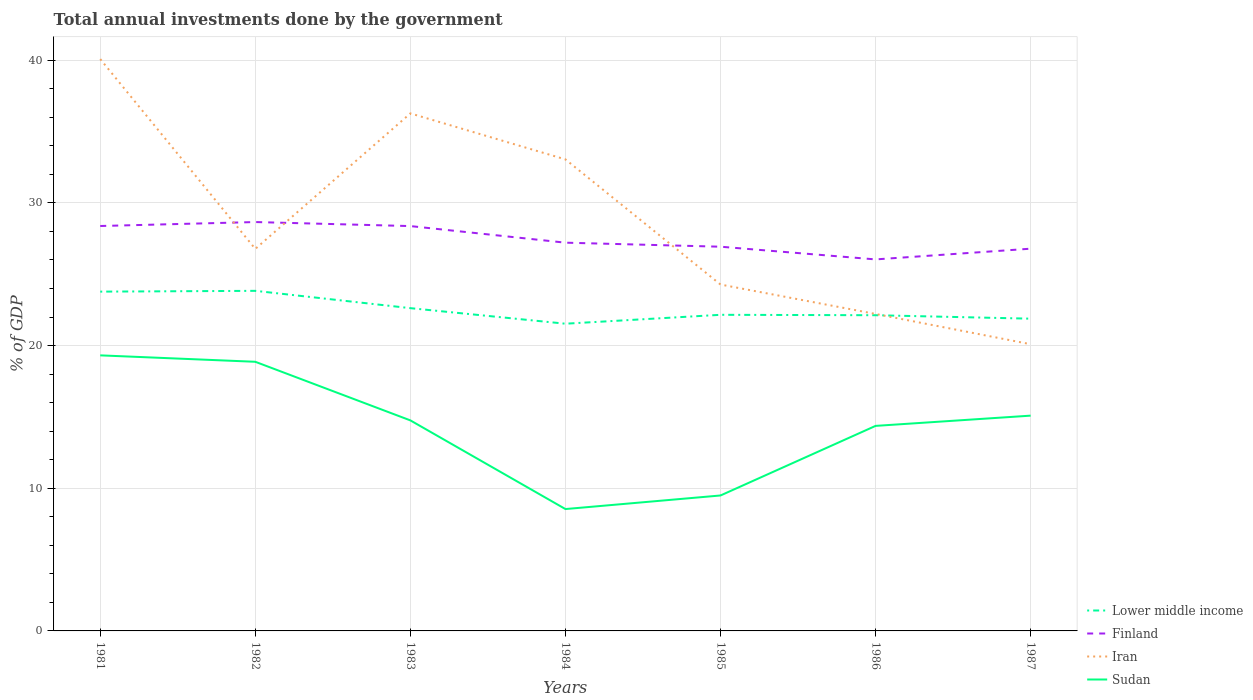How many different coloured lines are there?
Your response must be concise. 4. Does the line corresponding to Iran intersect with the line corresponding to Finland?
Ensure brevity in your answer.  Yes. Is the number of lines equal to the number of legend labels?
Make the answer very short. Yes. Across all years, what is the maximum total annual investments done by the government in Sudan?
Offer a very short reply. 8.54. In which year was the total annual investments done by the government in Iran maximum?
Offer a terse response. 1987. What is the total total annual investments done by the government in Sudan in the graph?
Your answer should be compact. 5.26. What is the difference between the highest and the second highest total annual investments done by the government in Lower middle income?
Provide a short and direct response. 2.3. What is the difference between the highest and the lowest total annual investments done by the government in Lower middle income?
Your answer should be very brief. 3. How many lines are there?
Provide a succinct answer. 4. How many years are there in the graph?
Your response must be concise. 7. Where does the legend appear in the graph?
Your answer should be very brief. Bottom right. How many legend labels are there?
Ensure brevity in your answer.  4. What is the title of the graph?
Your answer should be compact. Total annual investments done by the government. Does "Brunei Darussalam" appear as one of the legend labels in the graph?
Give a very brief answer. No. What is the label or title of the X-axis?
Ensure brevity in your answer.  Years. What is the label or title of the Y-axis?
Make the answer very short. % of GDP. What is the % of GDP in Lower middle income in 1981?
Give a very brief answer. 23.78. What is the % of GDP of Finland in 1981?
Offer a very short reply. 28.38. What is the % of GDP in Iran in 1981?
Ensure brevity in your answer.  40.08. What is the % of GDP in Sudan in 1981?
Your answer should be very brief. 19.31. What is the % of GDP in Lower middle income in 1982?
Keep it short and to the point. 23.83. What is the % of GDP in Finland in 1982?
Your response must be concise. 28.65. What is the % of GDP of Iran in 1982?
Provide a succinct answer. 26.77. What is the % of GDP in Sudan in 1982?
Provide a short and direct response. 18.86. What is the % of GDP in Lower middle income in 1983?
Provide a short and direct response. 22.62. What is the % of GDP of Finland in 1983?
Keep it short and to the point. 28.37. What is the % of GDP of Iran in 1983?
Provide a short and direct response. 36.27. What is the % of GDP in Sudan in 1983?
Your response must be concise. 14.75. What is the % of GDP of Lower middle income in 1984?
Give a very brief answer. 21.53. What is the % of GDP of Finland in 1984?
Provide a succinct answer. 27.21. What is the % of GDP in Iran in 1984?
Ensure brevity in your answer.  33.05. What is the % of GDP in Sudan in 1984?
Provide a short and direct response. 8.54. What is the % of GDP in Lower middle income in 1985?
Provide a short and direct response. 22.15. What is the % of GDP of Finland in 1985?
Offer a very short reply. 26.93. What is the % of GDP in Iran in 1985?
Your response must be concise. 24.27. What is the % of GDP in Sudan in 1985?
Make the answer very short. 9.49. What is the % of GDP of Lower middle income in 1986?
Provide a short and direct response. 22.13. What is the % of GDP of Finland in 1986?
Your answer should be compact. 26.04. What is the % of GDP in Iran in 1986?
Your answer should be compact. 22.21. What is the % of GDP of Sudan in 1986?
Keep it short and to the point. 14.37. What is the % of GDP in Lower middle income in 1987?
Keep it short and to the point. 21.88. What is the % of GDP of Finland in 1987?
Offer a terse response. 26.79. What is the % of GDP in Iran in 1987?
Your answer should be very brief. 20.09. What is the % of GDP in Sudan in 1987?
Offer a very short reply. 15.09. Across all years, what is the maximum % of GDP in Lower middle income?
Make the answer very short. 23.83. Across all years, what is the maximum % of GDP in Finland?
Provide a short and direct response. 28.65. Across all years, what is the maximum % of GDP of Iran?
Offer a terse response. 40.08. Across all years, what is the maximum % of GDP of Sudan?
Provide a short and direct response. 19.31. Across all years, what is the minimum % of GDP of Lower middle income?
Keep it short and to the point. 21.53. Across all years, what is the minimum % of GDP in Finland?
Keep it short and to the point. 26.04. Across all years, what is the minimum % of GDP of Iran?
Make the answer very short. 20.09. Across all years, what is the minimum % of GDP of Sudan?
Provide a short and direct response. 8.54. What is the total % of GDP of Lower middle income in the graph?
Your answer should be compact. 157.92. What is the total % of GDP in Finland in the graph?
Offer a terse response. 192.36. What is the total % of GDP in Iran in the graph?
Your response must be concise. 202.74. What is the total % of GDP of Sudan in the graph?
Make the answer very short. 100.42. What is the difference between the % of GDP of Lower middle income in 1981 and that in 1982?
Ensure brevity in your answer.  -0.06. What is the difference between the % of GDP in Finland in 1981 and that in 1982?
Keep it short and to the point. -0.28. What is the difference between the % of GDP of Iran in 1981 and that in 1982?
Offer a very short reply. 13.3. What is the difference between the % of GDP of Sudan in 1981 and that in 1982?
Keep it short and to the point. 0.45. What is the difference between the % of GDP in Lower middle income in 1981 and that in 1983?
Offer a terse response. 1.16. What is the difference between the % of GDP of Finland in 1981 and that in 1983?
Offer a very short reply. 0.01. What is the difference between the % of GDP of Iran in 1981 and that in 1983?
Give a very brief answer. 3.81. What is the difference between the % of GDP in Sudan in 1981 and that in 1983?
Offer a terse response. 4.56. What is the difference between the % of GDP of Lower middle income in 1981 and that in 1984?
Provide a succinct answer. 2.25. What is the difference between the % of GDP in Finland in 1981 and that in 1984?
Provide a succinct answer. 1.17. What is the difference between the % of GDP in Iran in 1981 and that in 1984?
Provide a short and direct response. 7.03. What is the difference between the % of GDP in Sudan in 1981 and that in 1984?
Offer a very short reply. 10.77. What is the difference between the % of GDP of Lower middle income in 1981 and that in 1985?
Provide a short and direct response. 1.62. What is the difference between the % of GDP of Finland in 1981 and that in 1985?
Give a very brief answer. 1.45. What is the difference between the % of GDP of Iran in 1981 and that in 1985?
Make the answer very short. 15.8. What is the difference between the % of GDP of Sudan in 1981 and that in 1985?
Your response must be concise. 9.82. What is the difference between the % of GDP in Lower middle income in 1981 and that in 1986?
Provide a succinct answer. 1.65. What is the difference between the % of GDP in Finland in 1981 and that in 1986?
Make the answer very short. 2.34. What is the difference between the % of GDP of Iran in 1981 and that in 1986?
Your response must be concise. 17.86. What is the difference between the % of GDP of Sudan in 1981 and that in 1986?
Offer a very short reply. 4.94. What is the difference between the % of GDP of Lower middle income in 1981 and that in 1987?
Provide a succinct answer. 1.9. What is the difference between the % of GDP in Finland in 1981 and that in 1987?
Provide a short and direct response. 1.59. What is the difference between the % of GDP in Iran in 1981 and that in 1987?
Your response must be concise. 19.98. What is the difference between the % of GDP of Sudan in 1981 and that in 1987?
Offer a very short reply. 4.22. What is the difference between the % of GDP in Lower middle income in 1982 and that in 1983?
Provide a succinct answer. 1.21. What is the difference between the % of GDP of Finland in 1982 and that in 1983?
Ensure brevity in your answer.  0.28. What is the difference between the % of GDP of Iran in 1982 and that in 1983?
Your answer should be compact. -9.5. What is the difference between the % of GDP in Sudan in 1982 and that in 1983?
Your answer should be compact. 4.11. What is the difference between the % of GDP in Lower middle income in 1982 and that in 1984?
Offer a terse response. 2.3. What is the difference between the % of GDP in Finland in 1982 and that in 1984?
Offer a terse response. 1.45. What is the difference between the % of GDP of Iran in 1982 and that in 1984?
Offer a terse response. -6.27. What is the difference between the % of GDP of Sudan in 1982 and that in 1984?
Make the answer very short. 10.32. What is the difference between the % of GDP of Lower middle income in 1982 and that in 1985?
Keep it short and to the point. 1.68. What is the difference between the % of GDP in Finland in 1982 and that in 1985?
Your response must be concise. 1.73. What is the difference between the % of GDP in Iran in 1982 and that in 1985?
Offer a terse response. 2.5. What is the difference between the % of GDP of Sudan in 1982 and that in 1985?
Offer a terse response. 9.37. What is the difference between the % of GDP of Lower middle income in 1982 and that in 1986?
Give a very brief answer. 1.71. What is the difference between the % of GDP in Finland in 1982 and that in 1986?
Offer a terse response. 2.62. What is the difference between the % of GDP of Iran in 1982 and that in 1986?
Keep it short and to the point. 4.56. What is the difference between the % of GDP of Sudan in 1982 and that in 1986?
Offer a terse response. 4.49. What is the difference between the % of GDP of Lower middle income in 1982 and that in 1987?
Offer a terse response. 1.95. What is the difference between the % of GDP in Finland in 1982 and that in 1987?
Make the answer very short. 1.87. What is the difference between the % of GDP of Iran in 1982 and that in 1987?
Give a very brief answer. 6.68. What is the difference between the % of GDP in Sudan in 1982 and that in 1987?
Keep it short and to the point. 3.77. What is the difference between the % of GDP of Lower middle income in 1983 and that in 1984?
Your answer should be compact. 1.09. What is the difference between the % of GDP in Finland in 1983 and that in 1984?
Your response must be concise. 1.16. What is the difference between the % of GDP in Iran in 1983 and that in 1984?
Your answer should be compact. 3.22. What is the difference between the % of GDP in Sudan in 1983 and that in 1984?
Offer a terse response. 6.21. What is the difference between the % of GDP of Lower middle income in 1983 and that in 1985?
Offer a terse response. 0.47. What is the difference between the % of GDP of Finland in 1983 and that in 1985?
Offer a very short reply. 1.45. What is the difference between the % of GDP of Iran in 1983 and that in 1985?
Offer a very short reply. 11.99. What is the difference between the % of GDP in Sudan in 1983 and that in 1985?
Provide a short and direct response. 5.26. What is the difference between the % of GDP of Lower middle income in 1983 and that in 1986?
Provide a succinct answer. 0.5. What is the difference between the % of GDP in Finland in 1983 and that in 1986?
Offer a terse response. 2.34. What is the difference between the % of GDP in Iran in 1983 and that in 1986?
Give a very brief answer. 14.06. What is the difference between the % of GDP in Sudan in 1983 and that in 1986?
Make the answer very short. 0.38. What is the difference between the % of GDP of Lower middle income in 1983 and that in 1987?
Keep it short and to the point. 0.74. What is the difference between the % of GDP of Finland in 1983 and that in 1987?
Ensure brevity in your answer.  1.58. What is the difference between the % of GDP of Iran in 1983 and that in 1987?
Give a very brief answer. 16.18. What is the difference between the % of GDP in Sudan in 1983 and that in 1987?
Your answer should be compact. -0.33. What is the difference between the % of GDP of Lower middle income in 1984 and that in 1985?
Give a very brief answer. -0.62. What is the difference between the % of GDP of Finland in 1984 and that in 1985?
Keep it short and to the point. 0.28. What is the difference between the % of GDP of Iran in 1984 and that in 1985?
Provide a succinct answer. 8.77. What is the difference between the % of GDP of Sudan in 1984 and that in 1985?
Give a very brief answer. -0.95. What is the difference between the % of GDP in Lower middle income in 1984 and that in 1986?
Offer a terse response. -0.59. What is the difference between the % of GDP of Finland in 1984 and that in 1986?
Make the answer very short. 1.17. What is the difference between the % of GDP in Iran in 1984 and that in 1986?
Make the answer very short. 10.83. What is the difference between the % of GDP in Sudan in 1984 and that in 1986?
Keep it short and to the point. -5.83. What is the difference between the % of GDP of Lower middle income in 1984 and that in 1987?
Your response must be concise. -0.35. What is the difference between the % of GDP of Finland in 1984 and that in 1987?
Offer a very short reply. 0.42. What is the difference between the % of GDP in Iran in 1984 and that in 1987?
Ensure brevity in your answer.  12.95. What is the difference between the % of GDP of Sudan in 1984 and that in 1987?
Make the answer very short. -6.55. What is the difference between the % of GDP of Lower middle income in 1985 and that in 1986?
Ensure brevity in your answer.  0.03. What is the difference between the % of GDP in Finland in 1985 and that in 1986?
Provide a short and direct response. 0.89. What is the difference between the % of GDP of Iran in 1985 and that in 1986?
Ensure brevity in your answer.  2.06. What is the difference between the % of GDP of Sudan in 1985 and that in 1986?
Your answer should be very brief. -4.88. What is the difference between the % of GDP of Lower middle income in 1985 and that in 1987?
Make the answer very short. 0.27. What is the difference between the % of GDP of Finland in 1985 and that in 1987?
Make the answer very short. 0.14. What is the difference between the % of GDP of Iran in 1985 and that in 1987?
Your answer should be very brief. 4.18. What is the difference between the % of GDP of Sudan in 1985 and that in 1987?
Provide a short and direct response. -5.59. What is the difference between the % of GDP of Lower middle income in 1986 and that in 1987?
Your answer should be compact. 0.24. What is the difference between the % of GDP of Finland in 1986 and that in 1987?
Your answer should be very brief. -0.75. What is the difference between the % of GDP of Iran in 1986 and that in 1987?
Keep it short and to the point. 2.12. What is the difference between the % of GDP in Sudan in 1986 and that in 1987?
Your answer should be very brief. -0.72. What is the difference between the % of GDP of Lower middle income in 1981 and the % of GDP of Finland in 1982?
Give a very brief answer. -4.88. What is the difference between the % of GDP in Lower middle income in 1981 and the % of GDP in Iran in 1982?
Your answer should be very brief. -3. What is the difference between the % of GDP of Lower middle income in 1981 and the % of GDP of Sudan in 1982?
Offer a terse response. 4.92. What is the difference between the % of GDP in Finland in 1981 and the % of GDP in Iran in 1982?
Make the answer very short. 1.6. What is the difference between the % of GDP of Finland in 1981 and the % of GDP of Sudan in 1982?
Your answer should be compact. 9.52. What is the difference between the % of GDP of Iran in 1981 and the % of GDP of Sudan in 1982?
Your answer should be compact. 21.21. What is the difference between the % of GDP of Lower middle income in 1981 and the % of GDP of Finland in 1983?
Your response must be concise. -4.59. What is the difference between the % of GDP of Lower middle income in 1981 and the % of GDP of Iran in 1983?
Your answer should be compact. -12.49. What is the difference between the % of GDP of Lower middle income in 1981 and the % of GDP of Sudan in 1983?
Your answer should be compact. 9.02. What is the difference between the % of GDP of Finland in 1981 and the % of GDP of Iran in 1983?
Ensure brevity in your answer.  -7.89. What is the difference between the % of GDP of Finland in 1981 and the % of GDP of Sudan in 1983?
Your answer should be compact. 13.62. What is the difference between the % of GDP of Iran in 1981 and the % of GDP of Sudan in 1983?
Offer a terse response. 25.32. What is the difference between the % of GDP in Lower middle income in 1981 and the % of GDP in Finland in 1984?
Provide a short and direct response. -3.43. What is the difference between the % of GDP in Lower middle income in 1981 and the % of GDP in Iran in 1984?
Give a very brief answer. -9.27. What is the difference between the % of GDP in Lower middle income in 1981 and the % of GDP in Sudan in 1984?
Your answer should be compact. 15.24. What is the difference between the % of GDP in Finland in 1981 and the % of GDP in Iran in 1984?
Make the answer very short. -4.67. What is the difference between the % of GDP of Finland in 1981 and the % of GDP of Sudan in 1984?
Your answer should be very brief. 19.84. What is the difference between the % of GDP of Iran in 1981 and the % of GDP of Sudan in 1984?
Offer a terse response. 31.54. What is the difference between the % of GDP of Lower middle income in 1981 and the % of GDP of Finland in 1985?
Your answer should be very brief. -3.15. What is the difference between the % of GDP of Lower middle income in 1981 and the % of GDP of Iran in 1985?
Make the answer very short. -0.5. What is the difference between the % of GDP of Lower middle income in 1981 and the % of GDP of Sudan in 1985?
Offer a very short reply. 14.29. What is the difference between the % of GDP of Finland in 1981 and the % of GDP of Iran in 1985?
Provide a succinct answer. 4.1. What is the difference between the % of GDP in Finland in 1981 and the % of GDP in Sudan in 1985?
Provide a succinct answer. 18.88. What is the difference between the % of GDP in Iran in 1981 and the % of GDP in Sudan in 1985?
Provide a short and direct response. 30.58. What is the difference between the % of GDP of Lower middle income in 1981 and the % of GDP of Finland in 1986?
Keep it short and to the point. -2.26. What is the difference between the % of GDP of Lower middle income in 1981 and the % of GDP of Iran in 1986?
Offer a terse response. 1.56. What is the difference between the % of GDP of Lower middle income in 1981 and the % of GDP of Sudan in 1986?
Offer a very short reply. 9.41. What is the difference between the % of GDP of Finland in 1981 and the % of GDP of Iran in 1986?
Offer a very short reply. 6.16. What is the difference between the % of GDP in Finland in 1981 and the % of GDP in Sudan in 1986?
Your answer should be very brief. 14.01. What is the difference between the % of GDP in Iran in 1981 and the % of GDP in Sudan in 1986?
Provide a succinct answer. 25.71. What is the difference between the % of GDP in Lower middle income in 1981 and the % of GDP in Finland in 1987?
Keep it short and to the point. -3.01. What is the difference between the % of GDP of Lower middle income in 1981 and the % of GDP of Iran in 1987?
Your response must be concise. 3.69. What is the difference between the % of GDP in Lower middle income in 1981 and the % of GDP in Sudan in 1987?
Make the answer very short. 8.69. What is the difference between the % of GDP in Finland in 1981 and the % of GDP in Iran in 1987?
Your answer should be compact. 8.28. What is the difference between the % of GDP of Finland in 1981 and the % of GDP of Sudan in 1987?
Ensure brevity in your answer.  13.29. What is the difference between the % of GDP of Iran in 1981 and the % of GDP of Sudan in 1987?
Your answer should be compact. 24.99. What is the difference between the % of GDP in Lower middle income in 1982 and the % of GDP in Finland in 1983?
Your response must be concise. -4.54. What is the difference between the % of GDP of Lower middle income in 1982 and the % of GDP of Iran in 1983?
Your answer should be very brief. -12.43. What is the difference between the % of GDP of Lower middle income in 1982 and the % of GDP of Sudan in 1983?
Your answer should be very brief. 9.08. What is the difference between the % of GDP of Finland in 1982 and the % of GDP of Iran in 1983?
Your response must be concise. -7.61. What is the difference between the % of GDP in Finland in 1982 and the % of GDP in Sudan in 1983?
Your response must be concise. 13.9. What is the difference between the % of GDP in Iran in 1982 and the % of GDP in Sudan in 1983?
Give a very brief answer. 12.02. What is the difference between the % of GDP in Lower middle income in 1982 and the % of GDP in Finland in 1984?
Your response must be concise. -3.38. What is the difference between the % of GDP in Lower middle income in 1982 and the % of GDP in Iran in 1984?
Your answer should be very brief. -9.21. What is the difference between the % of GDP in Lower middle income in 1982 and the % of GDP in Sudan in 1984?
Give a very brief answer. 15.29. What is the difference between the % of GDP of Finland in 1982 and the % of GDP of Iran in 1984?
Give a very brief answer. -4.39. What is the difference between the % of GDP of Finland in 1982 and the % of GDP of Sudan in 1984?
Your answer should be compact. 20.11. What is the difference between the % of GDP in Iran in 1982 and the % of GDP in Sudan in 1984?
Your answer should be very brief. 18.23. What is the difference between the % of GDP of Lower middle income in 1982 and the % of GDP of Finland in 1985?
Keep it short and to the point. -3.09. What is the difference between the % of GDP of Lower middle income in 1982 and the % of GDP of Iran in 1985?
Your answer should be very brief. -0.44. What is the difference between the % of GDP of Lower middle income in 1982 and the % of GDP of Sudan in 1985?
Your answer should be very brief. 14.34. What is the difference between the % of GDP of Finland in 1982 and the % of GDP of Iran in 1985?
Keep it short and to the point. 4.38. What is the difference between the % of GDP of Finland in 1982 and the % of GDP of Sudan in 1985?
Your response must be concise. 19.16. What is the difference between the % of GDP of Iran in 1982 and the % of GDP of Sudan in 1985?
Offer a terse response. 17.28. What is the difference between the % of GDP in Lower middle income in 1982 and the % of GDP in Finland in 1986?
Your answer should be compact. -2.2. What is the difference between the % of GDP in Lower middle income in 1982 and the % of GDP in Iran in 1986?
Keep it short and to the point. 1.62. What is the difference between the % of GDP in Lower middle income in 1982 and the % of GDP in Sudan in 1986?
Give a very brief answer. 9.46. What is the difference between the % of GDP of Finland in 1982 and the % of GDP of Iran in 1986?
Ensure brevity in your answer.  6.44. What is the difference between the % of GDP in Finland in 1982 and the % of GDP in Sudan in 1986?
Provide a short and direct response. 14.29. What is the difference between the % of GDP of Iran in 1982 and the % of GDP of Sudan in 1986?
Ensure brevity in your answer.  12.4. What is the difference between the % of GDP in Lower middle income in 1982 and the % of GDP in Finland in 1987?
Your answer should be very brief. -2.95. What is the difference between the % of GDP of Lower middle income in 1982 and the % of GDP of Iran in 1987?
Provide a succinct answer. 3.74. What is the difference between the % of GDP of Lower middle income in 1982 and the % of GDP of Sudan in 1987?
Your answer should be very brief. 8.75. What is the difference between the % of GDP of Finland in 1982 and the % of GDP of Iran in 1987?
Ensure brevity in your answer.  8.56. What is the difference between the % of GDP in Finland in 1982 and the % of GDP in Sudan in 1987?
Your answer should be compact. 13.57. What is the difference between the % of GDP of Iran in 1982 and the % of GDP of Sudan in 1987?
Give a very brief answer. 11.69. What is the difference between the % of GDP in Lower middle income in 1983 and the % of GDP in Finland in 1984?
Your answer should be compact. -4.59. What is the difference between the % of GDP of Lower middle income in 1983 and the % of GDP of Iran in 1984?
Ensure brevity in your answer.  -10.43. What is the difference between the % of GDP of Lower middle income in 1983 and the % of GDP of Sudan in 1984?
Offer a terse response. 14.08. What is the difference between the % of GDP of Finland in 1983 and the % of GDP of Iran in 1984?
Provide a succinct answer. -4.67. What is the difference between the % of GDP of Finland in 1983 and the % of GDP of Sudan in 1984?
Ensure brevity in your answer.  19.83. What is the difference between the % of GDP in Iran in 1983 and the % of GDP in Sudan in 1984?
Your response must be concise. 27.73. What is the difference between the % of GDP of Lower middle income in 1983 and the % of GDP of Finland in 1985?
Offer a very short reply. -4.31. What is the difference between the % of GDP of Lower middle income in 1983 and the % of GDP of Iran in 1985?
Provide a short and direct response. -1.65. What is the difference between the % of GDP of Lower middle income in 1983 and the % of GDP of Sudan in 1985?
Your response must be concise. 13.13. What is the difference between the % of GDP of Finland in 1983 and the % of GDP of Iran in 1985?
Provide a short and direct response. 4.1. What is the difference between the % of GDP in Finland in 1983 and the % of GDP in Sudan in 1985?
Provide a succinct answer. 18.88. What is the difference between the % of GDP of Iran in 1983 and the % of GDP of Sudan in 1985?
Keep it short and to the point. 26.78. What is the difference between the % of GDP of Lower middle income in 1983 and the % of GDP of Finland in 1986?
Provide a short and direct response. -3.42. What is the difference between the % of GDP in Lower middle income in 1983 and the % of GDP in Iran in 1986?
Make the answer very short. 0.41. What is the difference between the % of GDP of Lower middle income in 1983 and the % of GDP of Sudan in 1986?
Make the answer very short. 8.25. What is the difference between the % of GDP in Finland in 1983 and the % of GDP in Iran in 1986?
Keep it short and to the point. 6.16. What is the difference between the % of GDP in Finland in 1983 and the % of GDP in Sudan in 1986?
Offer a very short reply. 14. What is the difference between the % of GDP of Iran in 1983 and the % of GDP of Sudan in 1986?
Your answer should be compact. 21.9. What is the difference between the % of GDP in Lower middle income in 1983 and the % of GDP in Finland in 1987?
Offer a terse response. -4.17. What is the difference between the % of GDP in Lower middle income in 1983 and the % of GDP in Iran in 1987?
Make the answer very short. 2.53. What is the difference between the % of GDP of Lower middle income in 1983 and the % of GDP of Sudan in 1987?
Provide a succinct answer. 7.53. What is the difference between the % of GDP in Finland in 1983 and the % of GDP in Iran in 1987?
Offer a terse response. 8.28. What is the difference between the % of GDP of Finland in 1983 and the % of GDP of Sudan in 1987?
Provide a short and direct response. 13.29. What is the difference between the % of GDP of Iran in 1983 and the % of GDP of Sudan in 1987?
Ensure brevity in your answer.  21.18. What is the difference between the % of GDP of Lower middle income in 1984 and the % of GDP of Finland in 1985?
Ensure brevity in your answer.  -5.4. What is the difference between the % of GDP of Lower middle income in 1984 and the % of GDP of Iran in 1985?
Offer a terse response. -2.74. What is the difference between the % of GDP in Lower middle income in 1984 and the % of GDP in Sudan in 1985?
Your answer should be compact. 12.04. What is the difference between the % of GDP in Finland in 1984 and the % of GDP in Iran in 1985?
Provide a short and direct response. 2.93. What is the difference between the % of GDP in Finland in 1984 and the % of GDP in Sudan in 1985?
Offer a terse response. 17.72. What is the difference between the % of GDP in Iran in 1984 and the % of GDP in Sudan in 1985?
Offer a very short reply. 23.55. What is the difference between the % of GDP in Lower middle income in 1984 and the % of GDP in Finland in 1986?
Offer a terse response. -4.51. What is the difference between the % of GDP of Lower middle income in 1984 and the % of GDP of Iran in 1986?
Offer a very short reply. -0.68. What is the difference between the % of GDP of Lower middle income in 1984 and the % of GDP of Sudan in 1986?
Offer a terse response. 7.16. What is the difference between the % of GDP in Finland in 1984 and the % of GDP in Iran in 1986?
Offer a very short reply. 5. What is the difference between the % of GDP of Finland in 1984 and the % of GDP of Sudan in 1986?
Ensure brevity in your answer.  12.84. What is the difference between the % of GDP in Iran in 1984 and the % of GDP in Sudan in 1986?
Your answer should be very brief. 18.68. What is the difference between the % of GDP in Lower middle income in 1984 and the % of GDP in Finland in 1987?
Your answer should be compact. -5.26. What is the difference between the % of GDP in Lower middle income in 1984 and the % of GDP in Iran in 1987?
Your response must be concise. 1.44. What is the difference between the % of GDP of Lower middle income in 1984 and the % of GDP of Sudan in 1987?
Provide a short and direct response. 6.44. What is the difference between the % of GDP of Finland in 1984 and the % of GDP of Iran in 1987?
Keep it short and to the point. 7.12. What is the difference between the % of GDP of Finland in 1984 and the % of GDP of Sudan in 1987?
Keep it short and to the point. 12.12. What is the difference between the % of GDP in Iran in 1984 and the % of GDP in Sudan in 1987?
Offer a terse response. 17.96. What is the difference between the % of GDP of Lower middle income in 1985 and the % of GDP of Finland in 1986?
Make the answer very short. -3.88. What is the difference between the % of GDP in Lower middle income in 1985 and the % of GDP in Iran in 1986?
Your answer should be very brief. -0.06. What is the difference between the % of GDP in Lower middle income in 1985 and the % of GDP in Sudan in 1986?
Your answer should be very brief. 7.78. What is the difference between the % of GDP of Finland in 1985 and the % of GDP of Iran in 1986?
Ensure brevity in your answer.  4.71. What is the difference between the % of GDP of Finland in 1985 and the % of GDP of Sudan in 1986?
Your response must be concise. 12.56. What is the difference between the % of GDP of Iran in 1985 and the % of GDP of Sudan in 1986?
Your response must be concise. 9.91. What is the difference between the % of GDP of Lower middle income in 1985 and the % of GDP of Finland in 1987?
Give a very brief answer. -4.63. What is the difference between the % of GDP in Lower middle income in 1985 and the % of GDP in Iran in 1987?
Your answer should be compact. 2.06. What is the difference between the % of GDP in Lower middle income in 1985 and the % of GDP in Sudan in 1987?
Your answer should be very brief. 7.07. What is the difference between the % of GDP in Finland in 1985 and the % of GDP in Iran in 1987?
Your response must be concise. 6.83. What is the difference between the % of GDP of Finland in 1985 and the % of GDP of Sudan in 1987?
Offer a very short reply. 11.84. What is the difference between the % of GDP of Iran in 1985 and the % of GDP of Sudan in 1987?
Ensure brevity in your answer.  9.19. What is the difference between the % of GDP of Lower middle income in 1986 and the % of GDP of Finland in 1987?
Provide a succinct answer. -4.66. What is the difference between the % of GDP of Lower middle income in 1986 and the % of GDP of Iran in 1987?
Offer a terse response. 2.03. What is the difference between the % of GDP in Lower middle income in 1986 and the % of GDP in Sudan in 1987?
Your answer should be compact. 7.04. What is the difference between the % of GDP in Finland in 1986 and the % of GDP in Iran in 1987?
Your answer should be compact. 5.94. What is the difference between the % of GDP of Finland in 1986 and the % of GDP of Sudan in 1987?
Give a very brief answer. 10.95. What is the difference between the % of GDP in Iran in 1986 and the % of GDP in Sudan in 1987?
Your answer should be very brief. 7.13. What is the average % of GDP in Lower middle income per year?
Your answer should be compact. 22.56. What is the average % of GDP of Finland per year?
Provide a succinct answer. 27.48. What is the average % of GDP in Iran per year?
Offer a very short reply. 28.96. What is the average % of GDP in Sudan per year?
Your response must be concise. 14.35. In the year 1981, what is the difference between the % of GDP in Lower middle income and % of GDP in Finland?
Your answer should be very brief. -4.6. In the year 1981, what is the difference between the % of GDP of Lower middle income and % of GDP of Iran?
Keep it short and to the point. -16.3. In the year 1981, what is the difference between the % of GDP in Lower middle income and % of GDP in Sudan?
Ensure brevity in your answer.  4.47. In the year 1981, what is the difference between the % of GDP in Finland and % of GDP in Iran?
Provide a succinct answer. -11.7. In the year 1981, what is the difference between the % of GDP of Finland and % of GDP of Sudan?
Provide a succinct answer. 9.07. In the year 1981, what is the difference between the % of GDP of Iran and % of GDP of Sudan?
Offer a terse response. 20.76. In the year 1982, what is the difference between the % of GDP in Lower middle income and % of GDP in Finland?
Give a very brief answer. -4.82. In the year 1982, what is the difference between the % of GDP in Lower middle income and % of GDP in Iran?
Your response must be concise. -2.94. In the year 1982, what is the difference between the % of GDP of Lower middle income and % of GDP of Sudan?
Offer a very short reply. 4.97. In the year 1982, what is the difference between the % of GDP in Finland and % of GDP in Iran?
Offer a very short reply. 1.88. In the year 1982, what is the difference between the % of GDP in Finland and % of GDP in Sudan?
Ensure brevity in your answer.  9.79. In the year 1982, what is the difference between the % of GDP of Iran and % of GDP of Sudan?
Your answer should be very brief. 7.91. In the year 1983, what is the difference between the % of GDP in Lower middle income and % of GDP in Finland?
Offer a terse response. -5.75. In the year 1983, what is the difference between the % of GDP of Lower middle income and % of GDP of Iran?
Ensure brevity in your answer.  -13.65. In the year 1983, what is the difference between the % of GDP of Lower middle income and % of GDP of Sudan?
Your response must be concise. 7.87. In the year 1983, what is the difference between the % of GDP in Finland and % of GDP in Iran?
Your answer should be compact. -7.9. In the year 1983, what is the difference between the % of GDP in Finland and % of GDP in Sudan?
Your answer should be compact. 13.62. In the year 1983, what is the difference between the % of GDP of Iran and % of GDP of Sudan?
Give a very brief answer. 21.51. In the year 1984, what is the difference between the % of GDP of Lower middle income and % of GDP of Finland?
Provide a succinct answer. -5.68. In the year 1984, what is the difference between the % of GDP of Lower middle income and % of GDP of Iran?
Ensure brevity in your answer.  -11.52. In the year 1984, what is the difference between the % of GDP in Lower middle income and % of GDP in Sudan?
Provide a succinct answer. 12.99. In the year 1984, what is the difference between the % of GDP of Finland and % of GDP of Iran?
Keep it short and to the point. -5.84. In the year 1984, what is the difference between the % of GDP in Finland and % of GDP in Sudan?
Your answer should be compact. 18.67. In the year 1984, what is the difference between the % of GDP of Iran and % of GDP of Sudan?
Your answer should be very brief. 24.5. In the year 1985, what is the difference between the % of GDP of Lower middle income and % of GDP of Finland?
Provide a short and direct response. -4.77. In the year 1985, what is the difference between the % of GDP of Lower middle income and % of GDP of Iran?
Offer a terse response. -2.12. In the year 1985, what is the difference between the % of GDP in Lower middle income and % of GDP in Sudan?
Your answer should be very brief. 12.66. In the year 1985, what is the difference between the % of GDP of Finland and % of GDP of Iran?
Your response must be concise. 2.65. In the year 1985, what is the difference between the % of GDP in Finland and % of GDP in Sudan?
Provide a short and direct response. 17.43. In the year 1985, what is the difference between the % of GDP of Iran and % of GDP of Sudan?
Ensure brevity in your answer.  14.78. In the year 1986, what is the difference between the % of GDP of Lower middle income and % of GDP of Finland?
Ensure brevity in your answer.  -3.91. In the year 1986, what is the difference between the % of GDP in Lower middle income and % of GDP in Iran?
Provide a short and direct response. -0.09. In the year 1986, what is the difference between the % of GDP of Lower middle income and % of GDP of Sudan?
Make the answer very short. 7.76. In the year 1986, what is the difference between the % of GDP in Finland and % of GDP in Iran?
Ensure brevity in your answer.  3.82. In the year 1986, what is the difference between the % of GDP in Finland and % of GDP in Sudan?
Offer a terse response. 11.67. In the year 1986, what is the difference between the % of GDP of Iran and % of GDP of Sudan?
Make the answer very short. 7.84. In the year 1987, what is the difference between the % of GDP of Lower middle income and % of GDP of Finland?
Provide a short and direct response. -4.91. In the year 1987, what is the difference between the % of GDP of Lower middle income and % of GDP of Iran?
Keep it short and to the point. 1.79. In the year 1987, what is the difference between the % of GDP of Lower middle income and % of GDP of Sudan?
Give a very brief answer. 6.8. In the year 1987, what is the difference between the % of GDP of Finland and % of GDP of Iran?
Make the answer very short. 6.69. In the year 1987, what is the difference between the % of GDP in Finland and % of GDP in Sudan?
Your answer should be compact. 11.7. In the year 1987, what is the difference between the % of GDP of Iran and % of GDP of Sudan?
Offer a very short reply. 5.01. What is the ratio of the % of GDP in Lower middle income in 1981 to that in 1982?
Your answer should be very brief. 1. What is the ratio of the % of GDP in Finland in 1981 to that in 1982?
Provide a succinct answer. 0.99. What is the ratio of the % of GDP in Iran in 1981 to that in 1982?
Ensure brevity in your answer.  1.5. What is the ratio of the % of GDP of Sudan in 1981 to that in 1982?
Offer a very short reply. 1.02. What is the ratio of the % of GDP of Lower middle income in 1981 to that in 1983?
Ensure brevity in your answer.  1.05. What is the ratio of the % of GDP of Finland in 1981 to that in 1983?
Provide a short and direct response. 1. What is the ratio of the % of GDP of Iran in 1981 to that in 1983?
Your answer should be compact. 1.1. What is the ratio of the % of GDP of Sudan in 1981 to that in 1983?
Your response must be concise. 1.31. What is the ratio of the % of GDP of Lower middle income in 1981 to that in 1984?
Your answer should be compact. 1.1. What is the ratio of the % of GDP in Finland in 1981 to that in 1984?
Make the answer very short. 1.04. What is the ratio of the % of GDP of Iran in 1981 to that in 1984?
Provide a short and direct response. 1.21. What is the ratio of the % of GDP in Sudan in 1981 to that in 1984?
Your answer should be compact. 2.26. What is the ratio of the % of GDP in Lower middle income in 1981 to that in 1985?
Ensure brevity in your answer.  1.07. What is the ratio of the % of GDP of Finland in 1981 to that in 1985?
Make the answer very short. 1.05. What is the ratio of the % of GDP of Iran in 1981 to that in 1985?
Keep it short and to the point. 1.65. What is the ratio of the % of GDP in Sudan in 1981 to that in 1985?
Your response must be concise. 2.03. What is the ratio of the % of GDP in Lower middle income in 1981 to that in 1986?
Offer a very short reply. 1.07. What is the ratio of the % of GDP in Finland in 1981 to that in 1986?
Give a very brief answer. 1.09. What is the ratio of the % of GDP of Iran in 1981 to that in 1986?
Your answer should be very brief. 1.8. What is the ratio of the % of GDP in Sudan in 1981 to that in 1986?
Provide a short and direct response. 1.34. What is the ratio of the % of GDP of Lower middle income in 1981 to that in 1987?
Provide a short and direct response. 1.09. What is the ratio of the % of GDP of Finland in 1981 to that in 1987?
Your response must be concise. 1.06. What is the ratio of the % of GDP in Iran in 1981 to that in 1987?
Provide a succinct answer. 1.99. What is the ratio of the % of GDP of Sudan in 1981 to that in 1987?
Your response must be concise. 1.28. What is the ratio of the % of GDP in Lower middle income in 1982 to that in 1983?
Keep it short and to the point. 1.05. What is the ratio of the % of GDP in Finland in 1982 to that in 1983?
Offer a terse response. 1.01. What is the ratio of the % of GDP of Iran in 1982 to that in 1983?
Your response must be concise. 0.74. What is the ratio of the % of GDP in Sudan in 1982 to that in 1983?
Keep it short and to the point. 1.28. What is the ratio of the % of GDP of Lower middle income in 1982 to that in 1984?
Your answer should be very brief. 1.11. What is the ratio of the % of GDP in Finland in 1982 to that in 1984?
Your answer should be compact. 1.05. What is the ratio of the % of GDP in Iran in 1982 to that in 1984?
Provide a short and direct response. 0.81. What is the ratio of the % of GDP of Sudan in 1982 to that in 1984?
Offer a very short reply. 2.21. What is the ratio of the % of GDP of Lower middle income in 1982 to that in 1985?
Offer a terse response. 1.08. What is the ratio of the % of GDP of Finland in 1982 to that in 1985?
Make the answer very short. 1.06. What is the ratio of the % of GDP of Iran in 1982 to that in 1985?
Your answer should be compact. 1.1. What is the ratio of the % of GDP in Sudan in 1982 to that in 1985?
Provide a short and direct response. 1.99. What is the ratio of the % of GDP of Lower middle income in 1982 to that in 1986?
Offer a very short reply. 1.08. What is the ratio of the % of GDP in Finland in 1982 to that in 1986?
Your answer should be very brief. 1.1. What is the ratio of the % of GDP in Iran in 1982 to that in 1986?
Your answer should be very brief. 1.21. What is the ratio of the % of GDP of Sudan in 1982 to that in 1986?
Offer a very short reply. 1.31. What is the ratio of the % of GDP of Lower middle income in 1982 to that in 1987?
Keep it short and to the point. 1.09. What is the ratio of the % of GDP of Finland in 1982 to that in 1987?
Ensure brevity in your answer.  1.07. What is the ratio of the % of GDP in Iran in 1982 to that in 1987?
Your answer should be very brief. 1.33. What is the ratio of the % of GDP of Sudan in 1982 to that in 1987?
Give a very brief answer. 1.25. What is the ratio of the % of GDP in Lower middle income in 1983 to that in 1984?
Make the answer very short. 1.05. What is the ratio of the % of GDP of Finland in 1983 to that in 1984?
Make the answer very short. 1.04. What is the ratio of the % of GDP of Iran in 1983 to that in 1984?
Give a very brief answer. 1.1. What is the ratio of the % of GDP in Sudan in 1983 to that in 1984?
Your answer should be very brief. 1.73. What is the ratio of the % of GDP of Lower middle income in 1983 to that in 1985?
Make the answer very short. 1.02. What is the ratio of the % of GDP of Finland in 1983 to that in 1985?
Offer a terse response. 1.05. What is the ratio of the % of GDP in Iran in 1983 to that in 1985?
Your answer should be very brief. 1.49. What is the ratio of the % of GDP in Sudan in 1983 to that in 1985?
Your answer should be compact. 1.55. What is the ratio of the % of GDP of Lower middle income in 1983 to that in 1986?
Provide a short and direct response. 1.02. What is the ratio of the % of GDP of Finland in 1983 to that in 1986?
Provide a short and direct response. 1.09. What is the ratio of the % of GDP in Iran in 1983 to that in 1986?
Your answer should be very brief. 1.63. What is the ratio of the % of GDP of Sudan in 1983 to that in 1986?
Give a very brief answer. 1.03. What is the ratio of the % of GDP of Lower middle income in 1983 to that in 1987?
Offer a very short reply. 1.03. What is the ratio of the % of GDP of Finland in 1983 to that in 1987?
Give a very brief answer. 1.06. What is the ratio of the % of GDP of Iran in 1983 to that in 1987?
Give a very brief answer. 1.8. What is the ratio of the % of GDP in Sudan in 1983 to that in 1987?
Offer a very short reply. 0.98. What is the ratio of the % of GDP of Lower middle income in 1984 to that in 1985?
Ensure brevity in your answer.  0.97. What is the ratio of the % of GDP of Finland in 1984 to that in 1985?
Keep it short and to the point. 1.01. What is the ratio of the % of GDP of Iran in 1984 to that in 1985?
Make the answer very short. 1.36. What is the ratio of the % of GDP of Sudan in 1984 to that in 1985?
Offer a terse response. 0.9. What is the ratio of the % of GDP in Lower middle income in 1984 to that in 1986?
Keep it short and to the point. 0.97. What is the ratio of the % of GDP of Finland in 1984 to that in 1986?
Provide a succinct answer. 1.04. What is the ratio of the % of GDP of Iran in 1984 to that in 1986?
Provide a short and direct response. 1.49. What is the ratio of the % of GDP in Sudan in 1984 to that in 1986?
Your answer should be compact. 0.59. What is the ratio of the % of GDP of Lower middle income in 1984 to that in 1987?
Your answer should be compact. 0.98. What is the ratio of the % of GDP in Finland in 1984 to that in 1987?
Your answer should be compact. 1.02. What is the ratio of the % of GDP in Iran in 1984 to that in 1987?
Keep it short and to the point. 1.64. What is the ratio of the % of GDP of Sudan in 1984 to that in 1987?
Make the answer very short. 0.57. What is the ratio of the % of GDP of Finland in 1985 to that in 1986?
Offer a very short reply. 1.03. What is the ratio of the % of GDP of Iran in 1985 to that in 1986?
Offer a terse response. 1.09. What is the ratio of the % of GDP of Sudan in 1985 to that in 1986?
Provide a succinct answer. 0.66. What is the ratio of the % of GDP of Lower middle income in 1985 to that in 1987?
Your response must be concise. 1.01. What is the ratio of the % of GDP in Finland in 1985 to that in 1987?
Provide a succinct answer. 1.01. What is the ratio of the % of GDP in Iran in 1985 to that in 1987?
Your response must be concise. 1.21. What is the ratio of the % of GDP in Sudan in 1985 to that in 1987?
Keep it short and to the point. 0.63. What is the ratio of the % of GDP in Lower middle income in 1986 to that in 1987?
Keep it short and to the point. 1.01. What is the ratio of the % of GDP in Finland in 1986 to that in 1987?
Offer a terse response. 0.97. What is the ratio of the % of GDP in Iran in 1986 to that in 1987?
Provide a short and direct response. 1.11. What is the ratio of the % of GDP in Sudan in 1986 to that in 1987?
Make the answer very short. 0.95. What is the difference between the highest and the second highest % of GDP of Lower middle income?
Offer a terse response. 0.06. What is the difference between the highest and the second highest % of GDP of Finland?
Keep it short and to the point. 0.28. What is the difference between the highest and the second highest % of GDP of Iran?
Your answer should be compact. 3.81. What is the difference between the highest and the second highest % of GDP of Sudan?
Offer a terse response. 0.45. What is the difference between the highest and the lowest % of GDP in Lower middle income?
Your response must be concise. 2.3. What is the difference between the highest and the lowest % of GDP in Finland?
Ensure brevity in your answer.  2.62. What is the difference between the highest and the lowest % of GDP in Iran?
Ensure brevity in your answer.  19.98. What is the difference between the highest and the lowest % of GDP in Sudan?
Offer a very short reply. 10.77. 